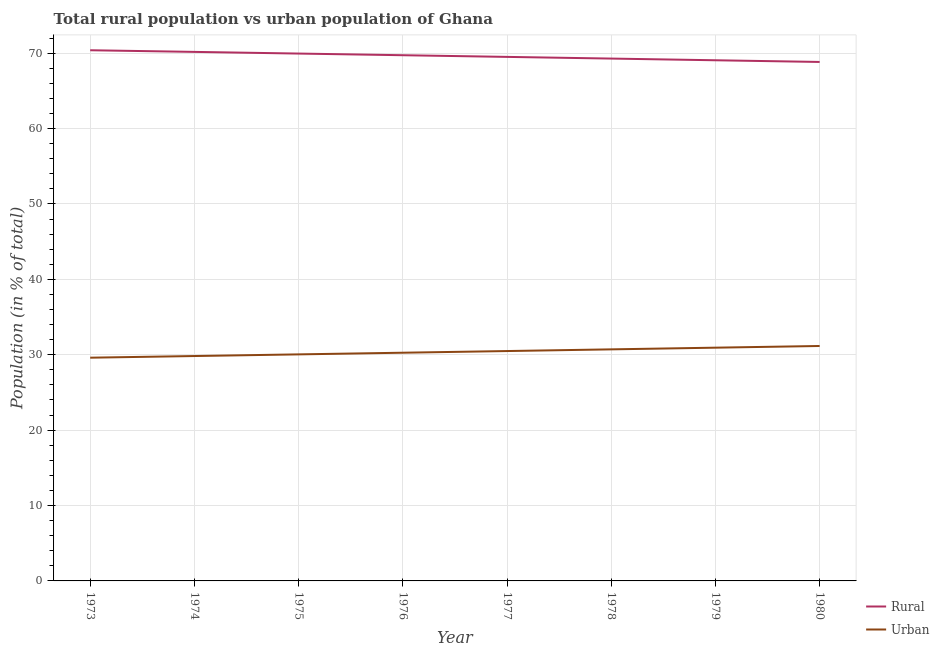Is the number of lines equal to the number of legend labels?
Your response must be concise. Yes. What is the urban population in 1973?
Provide a short and direct response. 29.61. Across all years, what is the maximum rural population?
Offer a very short reply. 70.39. Across all years, what is the minimum urban population?
Make the answer very short. 29.61. In which year was the rural population minimum?
Provide a succinct answer. 1980. What is the total rural population in the graph?
Provide a short and direct response. 556.93. What is the difference between the urban population in 1974 and that in 1980?
Provide a short and direct response. -1.33. What is the difference between the rural population in 1974 and the urban population in 1976?
Your answer should be very brief. 39.9. What is the average urban population per year?
Provide a succinct answer. 30.38. In the year 1974, what is the difference between the rural population and urban population?
Your response must be concise. 40.34. In how many years, is the rural population greater than 42 %?
Ensure brevity in your answer.  8. What is the ratio of the rural population in 1978 to that in 1980?
Offer a terse response. 1.01. What is the difference between the highest and the second highest rural population?
Offer a very short reply. 0.22. What is the difference between the highest and the lowest urban population?
Offer a terse response. 1.55. Is the rural population strictly greater than the urban population over the years?
Your answer should be compact. Yes. How many years are there in the graph?
Your response must be concise. 8. What is the difference between two consecutive major ticks on the Y-axis?
Ensure brevity in your answer.  10. Are the values on the major ticks of Y-axis written in scientific E-notation?
Your answer should be compact. No. Does the graph contain grids?
Your answer should be compact. Yes. What is the title of the graph?
Your answer should be very brief. Total rural population vs urban population of Ghana. What is the label or title of the X-axis?
Keep it short and to the point. Year. What is the label or title of the Y-axis?
Provide a succinct answer. Population (in % of total). What is the Population (in % of total) of Rural in 1973?
Provide a succinct answer. 70.39. What is the Population (in % of total) of Urban in 1973?
Your response must be concise. 29.61. What is the Population (in % of total) of Rural in 1974?
Provide a succinct answer. 70.17. What is the Population (in % of total) in Urban in 1974?
Provide a succinct answer. 29.83. What is the Population (in % of total) in Rural in 1975?
Your answer should be very brief. 69.95. What is the Population (in % of total) of Urban in 1975?
Offer a very short reply. 30.05. What is the Population (in % of total) of Rural in 1976?
Offer a very short reply. 69.73. What is the Population (in % of total) in Urban in 1976?
Your answer should be compact. 30.27. What is the Population (in % of total) of Rural in 1977?
Keep it short and to the point. 69.51. What is the Population (in % of total) in Urban in 1977?
Offer a terse response. 30.49. What is the Population (in % of total) of Rural in 1978?
Ensure brevity in your answer.  69.29. What is the Population (in % of total) of Urban in 1978?
Offer a terse response. 30.71. What is the Population (in % of total) of Rural in 1979?
Provide a short and direct response. 69.06. What is the Population (in % of total) in Urban in 1979?
Your answer should be compact. 30.94. What is the Population (in % of total) of Rural in 1980?
Keep it short and to the point. 68.84. What is the Population (in % of total) in Urban in 1980?
Your response must be concise. 31.16. Across all years, what is the maximum Population (in % of total) in Rural?
Offer a very short reply. 70.39. Across all years, what is the maximum Population (in % of total) in Urban?
Your answer should be compact. 31.16. Across all years, what is the minimum Population (in % of total) of Rural?
Your answer should be very brief. 68.84. Across all years, what is the minimum Population (in % of total) of Urban?
Offer a very short reply. 29.61. What is the total Population (in % of total) in Rural in the graph?
Keep it short and to the point. 556.93. What is the total Population (in % of total) of Urban in the graph?
Provide a short and direct response. 243.06. What is the difference between the Population (in % of total) in Rural in 1973 and that in 1974?
Offer a terse response. 0.22. What is the difference between the Population (in % of total) in Urban in 1973 and that in 1974?
Your answer should be compact. -0.22. What is the difference between the Population (in % of total) of Rural in 1973 and that in 1975?
Offer a very short reply. 0.44. What is the difference between the Population (in % of total) of Urban in 1973 and that in 1975?
Offer a very short reply. -0.44. What is the difference between the Population (in % of total) of Rural in 1973 and that in 1976?
Give a very brief answer. 0.66. What is the difference between the Population (in % of total) of Urban in 1973 and that in 1976?
Make the answer very short. -0.66. What is the difference between the Population (in % of total) of Rural in 1973 and that in 1977?
Offer a terse response. 0.88. What is the difference between the Population (in % of total) of Urban in 1973 and that in 1977?
Keep it short and to the point. -0.88. What is the difference between the Population (in % of total) in Rural in 1973 and that in 1978?
Your answer should be very brief. 1.1. What is the difference between the Population (in % of total) of Urban in 1973 and that in 1978?
Offer a terse response. -1.1. What is the difference between the Population (in % of total) of Rural in 1973 and that in 1979?
Keep it short and to the point. 1.33. What is the difference between the Population (in % of total) of Urban in 1973 and that in 1979?
Make the answer very short. -1.33. What is the difference between the Population (in % of total) in Rural in 1973 and that in 1980?
Make the answer very short. 1.55. What is the difference between the Population (in % of total) in Urban in 1973 and that in 1980?
Offer a terse response. -1.55. What is the difference between the Population (in % of total) of Rural in 1974 and that in 1975?
Ensure brevity in your answer.  0.22. What is the difference between the Population (in % of total) in Urban in 1974 and that in 1975?
Offer a very short reply. -0.22. What is the difference between the Population (in % of total) in Rural in 1974 and that in 1976?
Give a very brief answer. 0.44. What is the difference between the Population (in % of total) in Urban in 1974 and that in 1976?
Keep it short and to the point. -0.44. What is the difference between the Population (in % of total) of Rural in 1974 and that in 1977?
Provide a succinct answer. 0.66. What is the difference between the Population (in % of total) of Urban in 1974 and that in 1977?
Keep it short and to the point. -0.66. What is the difference between the Population (in % of total) in Rural in 1974 and that in 1978?
Your answer should be compact. 0.89. What is the difference between the Population (in % of total) in Urban in 1974 and that in 1978?
Your answer should be compact. -0.89. What is the difference between the Population (in % of total) in Rural in 1974 and that in 1979?
Offer a terse response. 1.11. What is the difference between the Population (in % of total) of Urban in 1974 and that in 1979?
Keep it short and to the point. -1.11. What is the difference between the Population (in % of total) in Rural in 1974 and that in 1980?
Your response must be concise. 1.33. What is the difference between the Population (in % of total) of Urban in 1974 and that in 1980?
Your answer should be compact. -1.33. What is the difference between the Population (in % of total) of Rural in 1975 and that in 1976?
Provide a succinct answer. 0.22. What is the difference between the Population (in % of total) in Urban in 1975 and that in 1976?
Keep it short and to the point. -0.22. What is the difference between the Population (in % of total) of Rural in 1975 and that in 1977?
Provide a short and direct response. 0.44. What is the difference between the Population (in % of total) of Urban in 1975 and that in 1977?
Your answer should be very brief. -0.44. What is the difference between the Population (in % of total) of Rural in 1975 and that in 1978?
Provide a succinct answer. 0.67. What is the difference between the Population (in % of total) in Urban in 1975 and that in 1978?
Your answer should be very brief. -0.67. What is the difference between the Population (in % of total) of Rural in 1975 and that in 1979?
Your response must be concise. 0.89. What is the difference between the Population (in % of total) of Urban in 1975 and that in 1979?
Make the answer very short. -0.89. What is the difference between the Population (in % of total) in Rural in 1975 and that in 1980?
Offer a terse response. 1.11. What is the difference between the Population (in % of total) of Urban in 1975 and that in 1980?
Make the answer very short. -1.11. What is the difference between the Population (in % of total) of Rural in 1976 and that in 1977?
Provide a short and direct response. 0.22. What is the difference between the Population (in % of total) in Urban in 1976 and that in 1977?
Provide a succinct answer. -0.22. What is the difference between the Population (in % of total) in Rural in 1976 and that in 1978?
Offer a terse response. 0.44. What is the difference between the Population (in % of total) in Urban in 1976 and that in 1978?
Give a very brief answer. -0.44. What is the difference between the Population (in % of total) of Rural in 1976 and that in 1979?
Provide a succinct answer. 0.67. What is the difference between the Population (in % of total) in Urban in 1976 and that in 1979?
Ensure brevity in your answer.  -0.67. What is the difference between the Population (in % of total) of Rural in 1976 and that in 1980?
Your response must be concise. 0.89. What is the difference between the Population (in % of total) of Urban in 1976 and that in 1980?
Your response must be concise. -0.89. What is the difference between the Population (in % of total) in Rural in 1977 and that in 1978?
Offer a terse response. 0.22. What is the difference between the Population (in % of total) in Urban in 1977 and that in 1978?
Give a very brief answer. -0.22. What is the difference between the Population (in % of total) in Rural in 1977 and that in 1979?
Make the answer very short. 0.45. What is the difference between the Population (in % of total) in Urban in 1977 and that in 1979?
Offer a very short reply. -0.45. What is the difference between the Population (in % of total) of Rural in 1977 and that in 1980?
Provide a succinct answer. 0.67. What is the difference between the Population (in % of total) of Urban in 1977 and that in 1980?
Give a very brief answer. -0.67. What is the difference between the Population (in % of total) of Rural in 1978 and that in 1979?
Provide a succinct answer. 0.22. What is the difference between the Population (in % of total) of Urban in 1978 and that in 1979?
Ensure brevity in your answer.  -0.22. What is the difference between the Population (in % of total) in Rural in 1978 and that in 1980?
Keep it short and to the point. 0.45. What is the difference between the Population (in % of total) in Urban in 1978 and that in 1980?
Give a very brief answer. -0.45. What is the difference between the Population (in % of total) of Rural in 1979 and that in 1980?
Offer a terse response. 0.23. What is the difference between the Population (in % of total) in Urban in 1979 and that in 1980?
Offer a very short reply. -0.23. What is the difference between the Population (in % of total) in Rural in 1973 and the Population (in % of total) in Urban in 1974?
Provide a succinct answer. 40.56. What is the difference between the Population (in % of total) in Rural in 1973 and the Population (in % of total) in Urban in 1975?
Offer a terse response. 40.34. What is the difference between the Population (in % of total) in Rural in 1973 and the Population (in % of total) in Urban in 1976?
Keep it short and to the point. 40.12. What is the difference between the Population (in % of total) of Rural in 1973 and the Population (in % of total) of Urban in 1977?
Provide a short and direct response. 39.9. What is the difference between the Population (in % of total) of Rural in 1973 and the Population (in % of total) of Urban in 1978?
Your answer should be very brief. 39.68. What is the difference between the Population (in % of total) of Rural in 1973 and the Population (in % of total) of Urban in 1979?
Make the answer very short. 39.45. What is the difference between the Population (in % of total) of Rural in 1973 and the Population (in % of total) of Urban in 1980?
Give a very brief answer. 39.23. What is the difference between the Population (in % of total) of Rural in 1974 and the Population (in % of total) of Urban in 1975?
Give a very brief answer. 40.12. What is the difference between the Population (in % of total) in Rural in 1974 and the Population (in % of total) in Urban in 1976?
Your answer should be very brief. 39.9. What is the difference between the Population (in % of total) in Rural in 1974 and the Population (in % of total) in Urban in 1977?
Your answer should be compact. 39.68. What is the difference between the Population (in % of total) of Rural in 1974 and the Population (in % of total) of Urban in 1978?
Provide a succinct answer. 39.46. What is the difference between the Population (in % of total) in Rural in 1974 and the Population (in % of total) in Urban in 1979?
Make the answer very short. 39.23. What is the difference between the Population (in % of total) in Rural in 1974 and the Population (in % of total) in Urban in 1980?
Your response must be concise. 39.01. What is the difference between the Population (in % of total) of Rural in 1975 and the Population (in % of total) of Urban in 1976?
Give a very brief answer. 39.68. What is the difference between the Population (in % of total) in Rural in 1975 and the Population (in % of total) in Urban in 1977?
Give a very brief answer. 39.46. What is the difference between the Population (in % of total) of Rural in 1975 and the Population (in % of total) of Urban in 1978?
Your response must be concise. 39.24. What is the difference between the Population (in % of total) in Rural in 1975 and the Population (in % of total) in Urban in 1979?
Ensure brevity in your answer.  39.01. What is the difference between the Population (in % of total) of Rural in 1975 and the Population (in % of total) of Urban in 1980?
Ensure brevity in your answer.  38.79. What is the difference between the Population (in % of total) in Rural in 1976 and the Population (in % of total) in Urban in 1977?
Provide a succinct answer. 39.24. What is the difference between the Population (in % of total) in Rural in 1976 and the Population (in % of total) in Urban in 1978?
Your answer should be compact. 39.02. What is the difference between the Population (in % of total) in Rural in 1976 and the Population (in % of total) in Urban in 1979?
Give a very brief answer. 38.79. What is the difference between the Population (in % of total) in Rural in 1976 and the Population (in % of total) in Urban in 1980?
Make the answer very short. 38.57. What is the difference between the Population (in % of total) of Rural in 1977 and the Population (in % of total) of Urban in 1978?
Offer a terse response. 38.79. What is the difference between the Population (in % of total) of Rural in 1977 and the Population (in % of total) of Urban in 1979?
Keep it short and to the point. 38.57. What is the difference between the Population (in % of total) of Rural in 1977 and the Population (in % of total) of Urban in 1980?
Offer a very short reply. 38.34. What is the difference between the Population (in % of total) of Rural in 1978 and the Population (in % of total) of Urban in 1979?
Your response must be concise. 38.35. What is the difference between the Population (in % of total) in Rural in 1978 and the Population (in % of total) in Urban in 1980?
Offer a terse response. 38.12. What is the difference between the Population (in % of total) in Rural in 1979 and the Population (in % of total) in Urban in 1980?
Provide a short and direct response. 37.9. What is the average Population (in % of total) of Rural per year?
Offer a terse response. 69.62. What is the average Population (in % of total) in Urban per year?
Your answer should be compact. 30.38. In the year 1973, what is the difference between the Population (in % of total) of Rural and Population (in % of total) of Urban?
Give a very brief answer. 40.78. In the year 1974, what is the difference between the Population (in % of total) in Rural and Population (in % of total) in Urban?
Your response must be concise. 40.34. In the year 1975, what is the difference between the Population (in % of total) of Rural and Population (in % of total) of Urban?
Ensure brevity in your answer.  39.9. In the year 1976, what is the difference between the Population (in % of total) in Rural and Population (in % of total) in Urban?
Your response must be concise. 39.46. In the year 1977, what is the difference between the Population (in % of total) of Rural and Population (in % of total) of Urban?
Make the answer very short. 39.02. In the year 1978, what is the difference between the Population (in % of total) of Rural and Population (in % of total) of Urban?
Give a very brief answer. 38.57. In the year 1979, what is the difference between the Population (in % of total) of Rural and Population (in % of total) of Urban?
Offer a very short reply. 38.12. In the year 1980, what is the difference between the Population (in % of total) of Rural and Population (in % of total) of Urban?
Offer a very short reply. 37.67. What is the ratio of the Population (in % of total) of Rural in 1973 to that in 1974?
Offer a terse response. 1. What is the ratio of the Population (in % of total) of Urban in 1973 to that in 1974?
Ensure brevity in your answer.  0.99. What is the ratio of the Population (in % of total) in Rural in 1973 to that in 1975?
Ensure brevity in your answer.  1.01. What is the ratio of the Population (in % of total) of Urban in 1973 to that in 1975?
Give a very brief answer. 0.99. What is the ratio of the Population (in % of total) of Rural in 1973 to that in 1976?
Your response must be concise. 1.01. What is the ratio of the Population (in % of total) in Urban in 1973 to that in 1976?
Give a very brief answer. 0.98. What is the ratio of the Population (in % of total) of Rural in 1973 to that in 1977?
Provide a succinct answer. 1.01. What is the ratio of the Population (in % of total) in Urban in 1973 to that in 1977?
Keep it short and to the point. 0.97. What is the ratio of the Population (in % of total) of Rural in 1973 to that in 1978?
Your response must be concise. 1.02. What is the ratio of the Population (in % of total) of Urban in 1973 to that in 1978?
Make the answer very short. 0.96. What is the ratio of the Population (in % of total) in Rural in 1973 to that in 1979?
Provide a succinct answer. 1.02. What is the ratio of the Population (in % of total) of Urban in 1973 to that in 1979?
Provide a short and direct response. 0.96. What is the ratio of the Population (in % of total) in Rural in 1973 to that in 1980?
Keep it short and to the point. 1.02. What is the ratio of the Population (in % of total) in Urban in 1973 to that in 1980?
Give a very brief answer. 0.95. What is the ratio of the Population (in % of total) of Rural in 1974 to that in 1975?
Ensure brevity in your answer.  1. What is the ratio of the Population (in % of total) in Urban in 1974 to that in 1975?
Provide a short and direct response. 0.99. What is the ratio of the Population (in % of total) in Rural in 1974 to that in 1976?
Provide a short and direct response. 1.01. What is the ratio of the Population (in % of total) of Urban in 1974 to that in 1976?
Keep it short and to the point. 0.99. What is the ratio of the Population (in % of total) of Rural in 1974 to that in 1977?
Your response must be concise. 1.01. What is the ratio of the Population (in % of total) of Urban in 1974 to that in 1977?
Your answer should be very brief. 0.98. What is the ratio of the Population (in % of total) of Rural in 1974 to that in 1978?
Offer a very short reply. 1.01. What is the ratio of the Population (in % of total) of Urban in 1974 to that in 1978?
Give a very brief answer. 0.97. What is the ratio of the Population (in % of total) in Rural in 1974 to that in 1979?
Offer a very short reply. 1.02. What is the ratio of the Population (in % of total) of Urban in 1974 to that in 1979?
Your answer should be compact. 0.96. What is the ratio of the Population (in % of total) of Rural in 1974 to that in 1980?
Offer a very short reply. 1.02. What is the ratio of the Population (in % of total) of Urban in 1974 to that in 1980?
Provide a succinct answer. 0.96. What is the ratio of the Population (in % of total) of Urban in 1975 to that in 1976?
Your answer should be compact. 0.99. What is the ratio of the Population (in % of total) of Rural in 1975 to that in 1977?
Your answer should be compact. 1.01. What is the ratio of the Population (in % of total) in Urban in 1975 to that in 1977?
Your answer should be compact. 0.99. What is the ratio of the Population (in % of total) of Rural in 1975 to that in 1978?
Your response must be concise. 1.01. What is the ratio of the Population (in % of total) of Urban in 1975 to that in 1978?
Your response must be concise. 0.98. What is the ratio of the Population (in % of total) of Rural in 1975 to that in 1979?
Your response must be concise. 1.01. What is the ratio of the Population (in % of total) of Urban in 1975 to that in 1979?
Keep it short and to the point. 0.97. What is the ratio of the Population (in % of total) of Rural in 1975 to that in 1980?
Your answer should be compact. 1.02. What is the ratio of the Population (in % of total) of Urban in 1975 to that in 1980?
Offer a very short reply. 0.96. What is the ratio of the Population (in % of total) of Rural in 1976 to that in 1977?
Provide a succinct answer. 1. What is the ratio of the Population (in % of total) of Rural in 1976 to that in 1978?
Your answer should be compact. 1.01. What is the ratio of the Population (in % of total) in Urban in 1976 to that in 1978?
Keep it short and to the point. 0.99. What is the ratio of the Population (in % of total) in Rural in 1976 to that in 1979?
Keep it short and to the point. 1.01. What is the ratio of the Population (in % of total) of Urban in 1976 to that in 1979?
Provide a short and direct response. 0.98. What is the ratio of the Population (in % of total) in Urban in 1976 to that in 1980?
Provide a succinct answer. 0.97. What is the ratio of the Population (in % of total) of Rural in 1977 to that in 1978?
Provide a succinct answer. 1. What is the ratio of the Population (in % of total) of Rural in 1977 to that in 1979?
Your answer should be very brief. 1.01. What is the ratio of the Population (in % of total) of Urban in 1977 to that in 1979?
Provide a succinct answer. 0.99. What is the ratio of the Population (in % of total) of Rural in 1977 to that in 1980?
Keep it short and to the point. 1.01. What is the ratio of the Population (in % of total) of Urban in 1977 to that in 1980?
Ensure brevity in your answer.  0.98. What is the ratio of the Population (in % of total) of Rural in 1978 to that in 1979?
Your response must be concise. 1. What is the ratio of the Population (in % of total) in Urban in 1978 to that in 1979?
Your answer should be compact. 0.99. What is the ratio of the Population (in % of total) in Rural in 1978 to that in 1980?
Provide a succinct answer. 1.01. What is the ratio of the Population (in % of total) in Urban in 1978 to that in 1980?
Ensure brevity in your answer.  0.99. What is the ratio of the Population (in % of total) of Rural in 1979 to that in 1980?
Offer a terse response. 1. What is the difference between the highest and the second highest Population (in % of total) in Rural?
Offer a terse response. 0.22. What is the difference between the highest and the second highest Population (in % of total) in Urban?
Keep it short and to the point. 0.23. What is the difference between the highest and the lowest Population (in % of total) in Rural?
Make the answer very short. 1.55. What is the difference between the highest and the lowest Population (in % of total) of Urban?
Provide a short and direct response. 1.55. 